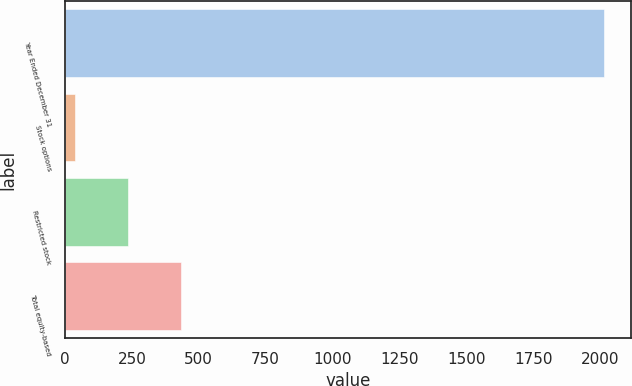Convert chart to OTSL. <chart><loc_0><loc_0><loc_500><loc_500><bar_chart><fcel>Year Ended December 31<fcel>Stock options<fcel>Restricted stock<fcel>Total equity-based<nl><fcel>2014<fcel>38<fcel>235.6<fcel>433.2<nl></chart> 